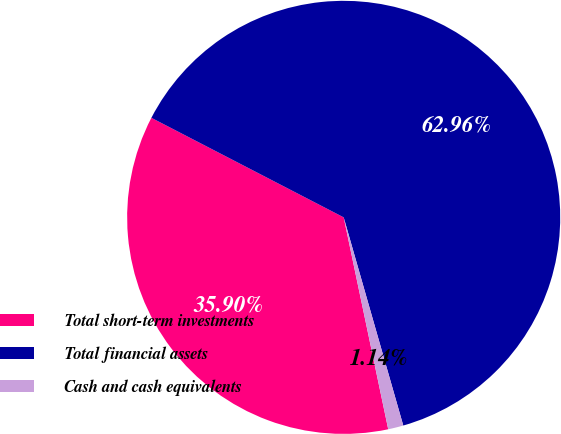<chart> <loc_0><loc_0><loc_500><loc_500><pie_chart><fcel>Total short-term investments<fcel>Total financial assets<fcel>Cash and cash equivalents<nl><fcel>35.9%<fcel>62.96%<fcel>1.14%<nl></chart> 